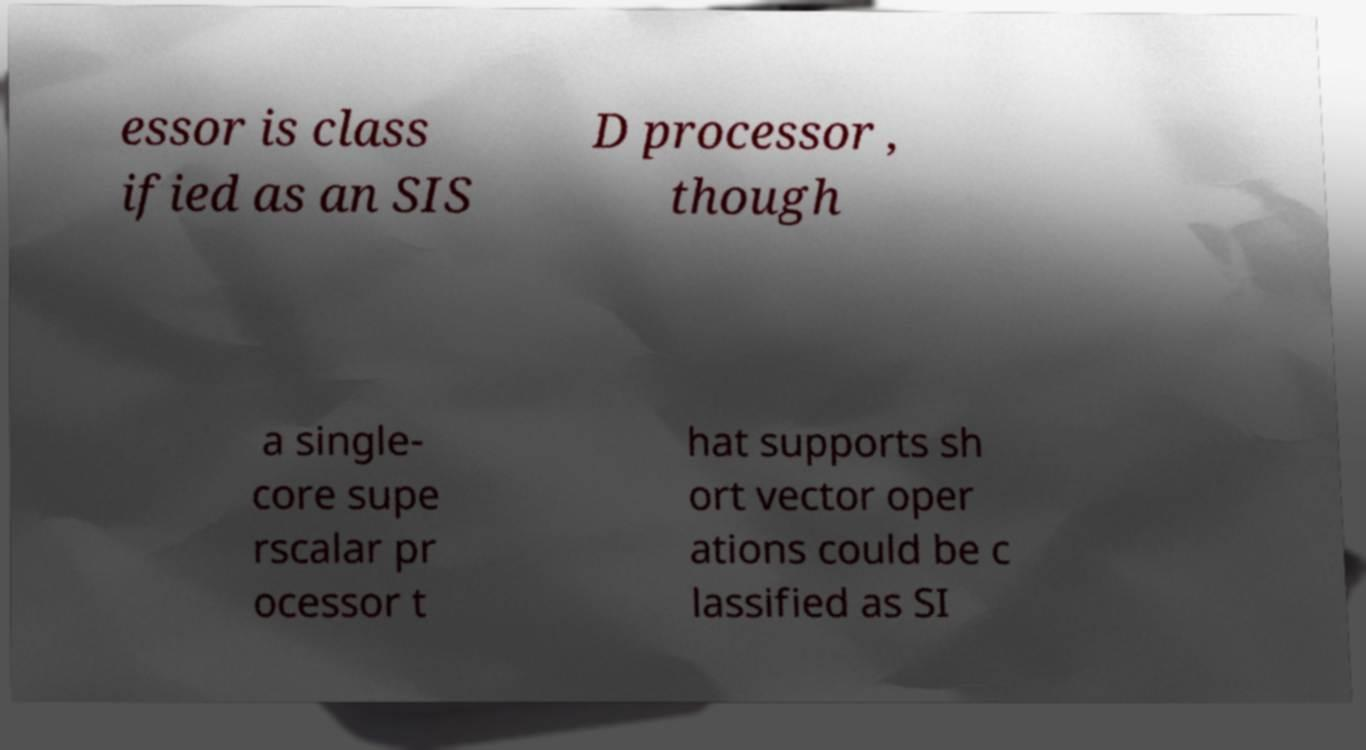Please identify and transcribe the text found in this image. essor is class ified as an SIS D processor , though a single- core supe rscalar pr ocessor t hat supports sh ort vector oper ations could be c lassified as SI 